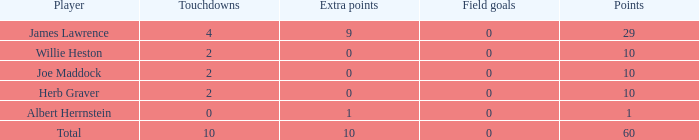Parse the table in full. {'header': ['Player', 'Touchdowns', 'Extra points', 'Field goals', 'Points'], 'rows': [['James Lawrence', '4', '9', '0', '29'], ['Willie Heston', '2', '0', '0', '10'], ['Joe Maddock', '2', '0', '0', '10'], ['Herb Graver', '2', '0', '0', '10'], ['Albert Herrnstein', '0', '1', '0', '1'], ['Total', '10', '10', '0', '60']]} What is the highest number of points for players with less than 2 touchdowns and 0 extra points? None. 